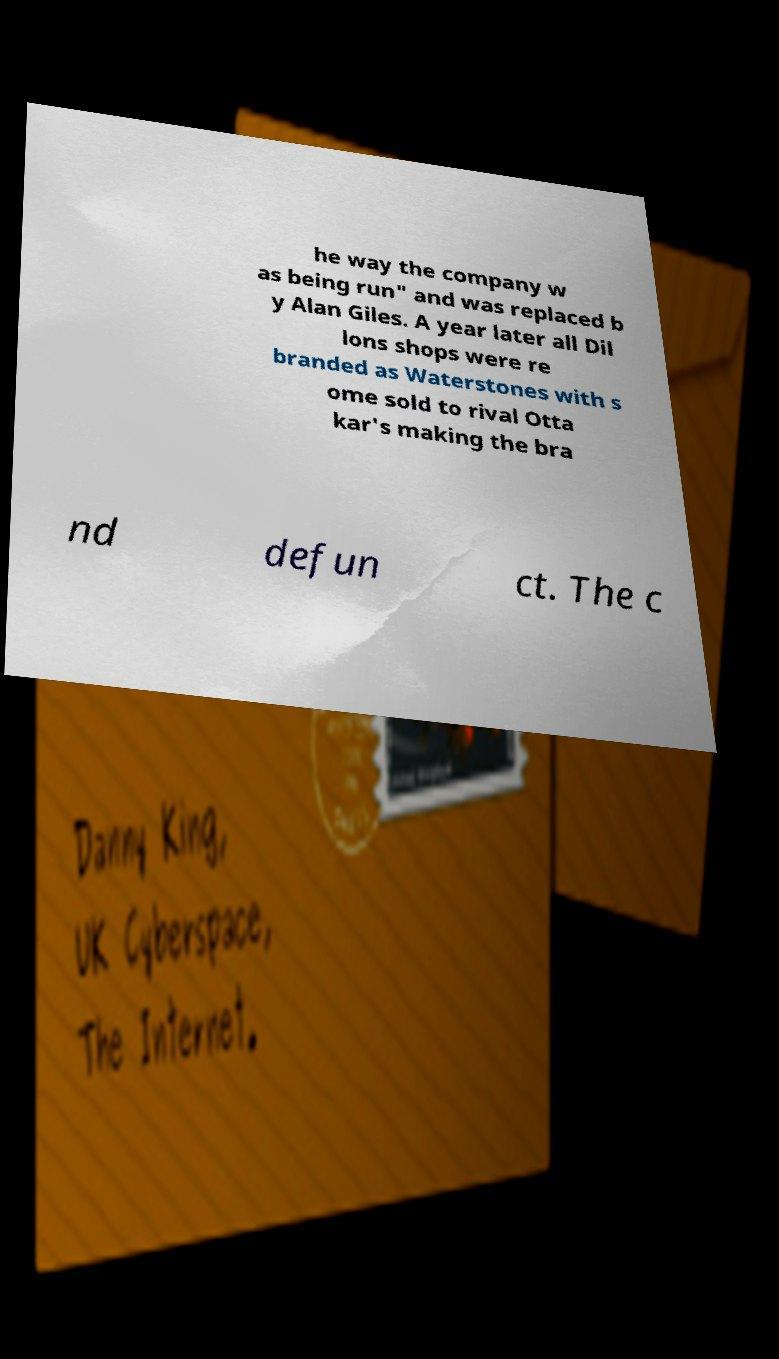I need the written content from this picture converted into text. Can you do that? he way the company w as being run" and was replaced b y Alan Giles. A year later all Dil lons shops were re branded as Waterstones with s ome sold to rival Otta kar's making the bra nd defun ct. The c 